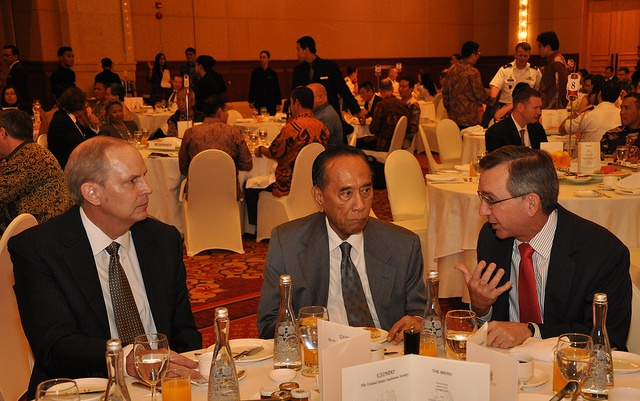Describe the objects in this image and their specific colors. I can see dining table in black, tan, brown, and maroon tones, people in black, maroon, and brown tones, people in black, brown, maroon, and salmon tones, people in black, maroon, brown, and salmon tones, and people in black, maroon, and brown tones in this image. 